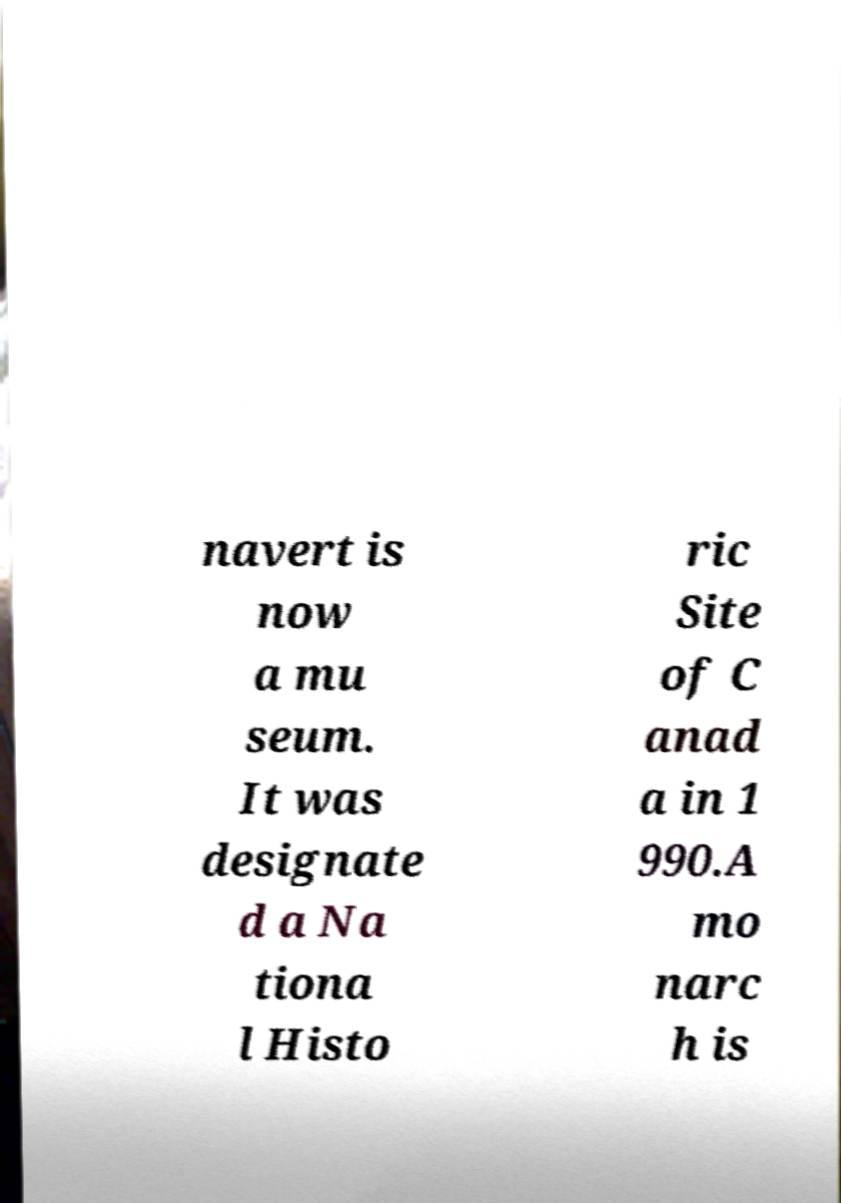Can you read and provide the text displayed in the image?This photo seems to have some interesting text. Can you extract and type it out for me? navert is now a mu seum. It was designate d a Na tiona l Histo ric Site of C anad a in 1 990.A mo narc h is 